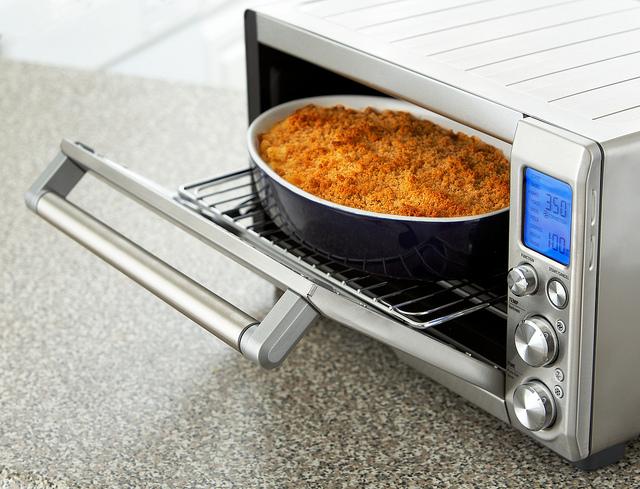What is the temperature of the oven?
Short answer required. 350. What sort of dish is in the oven?
Short answer required. Casserole. What is being cooked?
Answer briefly. Casserole. 